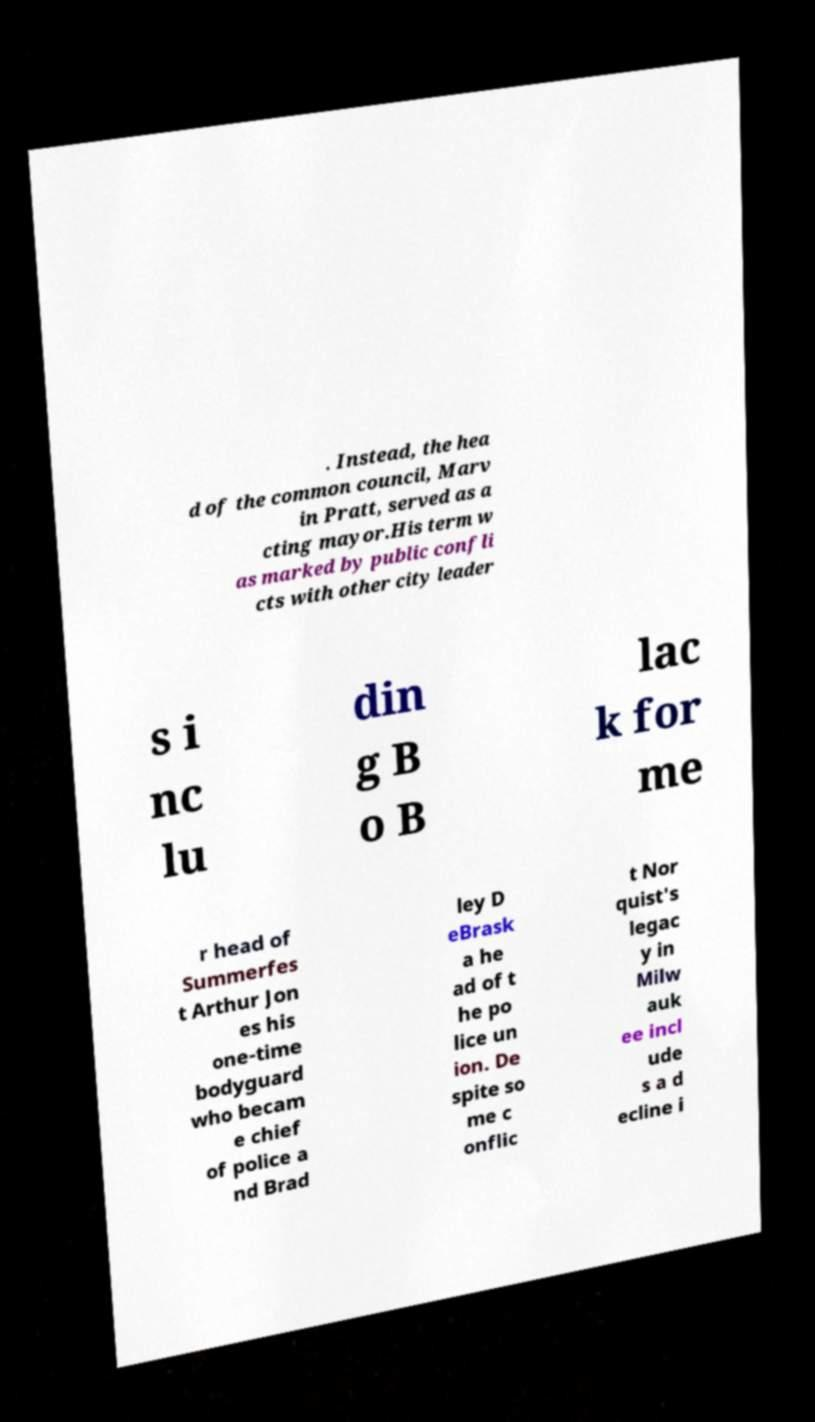What messages or text are displayed in this image? I need them in a readable, typed format. . Instead, the hea d of the common council, Marv in Pratt, served as a cting mayor.His term w as marked by public confli cts with other city leader s i nc lu din g B o B lac k for me r head of Summerfes t Arthur Jon es his one-time bodyguard who becam e chief of police a nd Brad ley D eBrask a he ad of t he po lice un ion. De spite so me c onflic t Nor quist's legac y in Milw auk ee incl ude s a d ecline i 